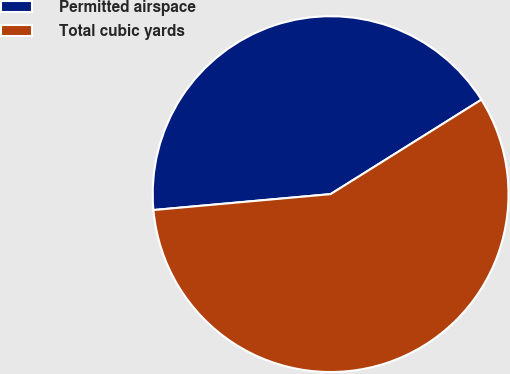<chart> <loc_0><loc_0><loc_500><loc_500><pie_chart><fcel>Permitted airspace<fcel>Total cubic yards<nl><fcel>42.52%<fcel>57.48%<nl></chart> 